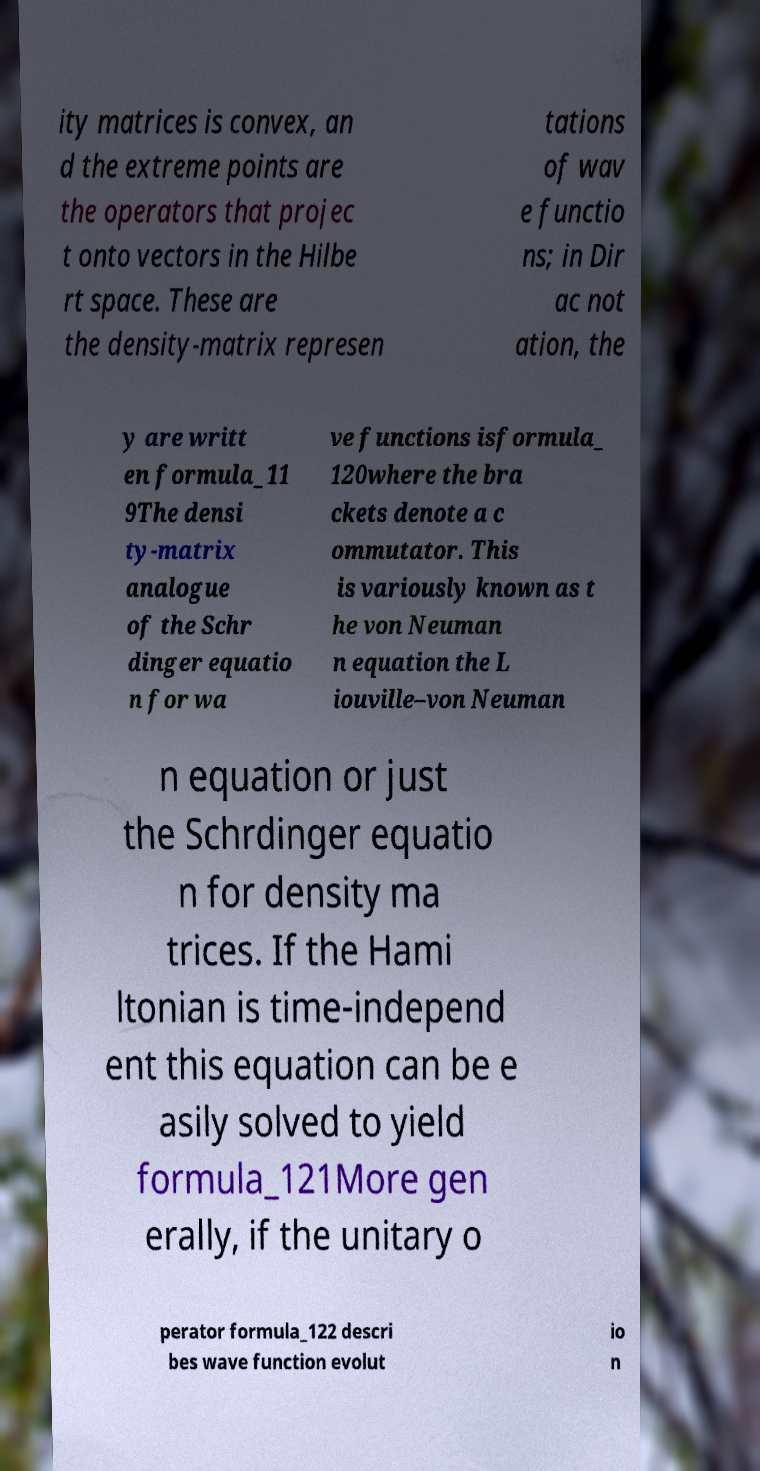Please identify and transcribe the text found in this image. ity matrices is convex, an d the extreme points are the operators that projec t onto vectors in the Hilbe rt space. These are the density-matrix represen tations of wav e functio ns; in Dir ac not ation, the y are writt en formula_11 9The densi ty-matrix analogue of the Schr dinger equatio n for wa ve functions isformula_ 120where the bra ckets denote a c ommutator. This is variously known as t he von Neuman n equation the L iouville–von Neuman n equation or just the Schrdinger equatio n for density ma trices. If the Hami ltonian is time-independ ent this equation can be e asily solved to yield formula_121More gen erally, if the unitary o perator formula_122 descri bes wave function evolut io n 